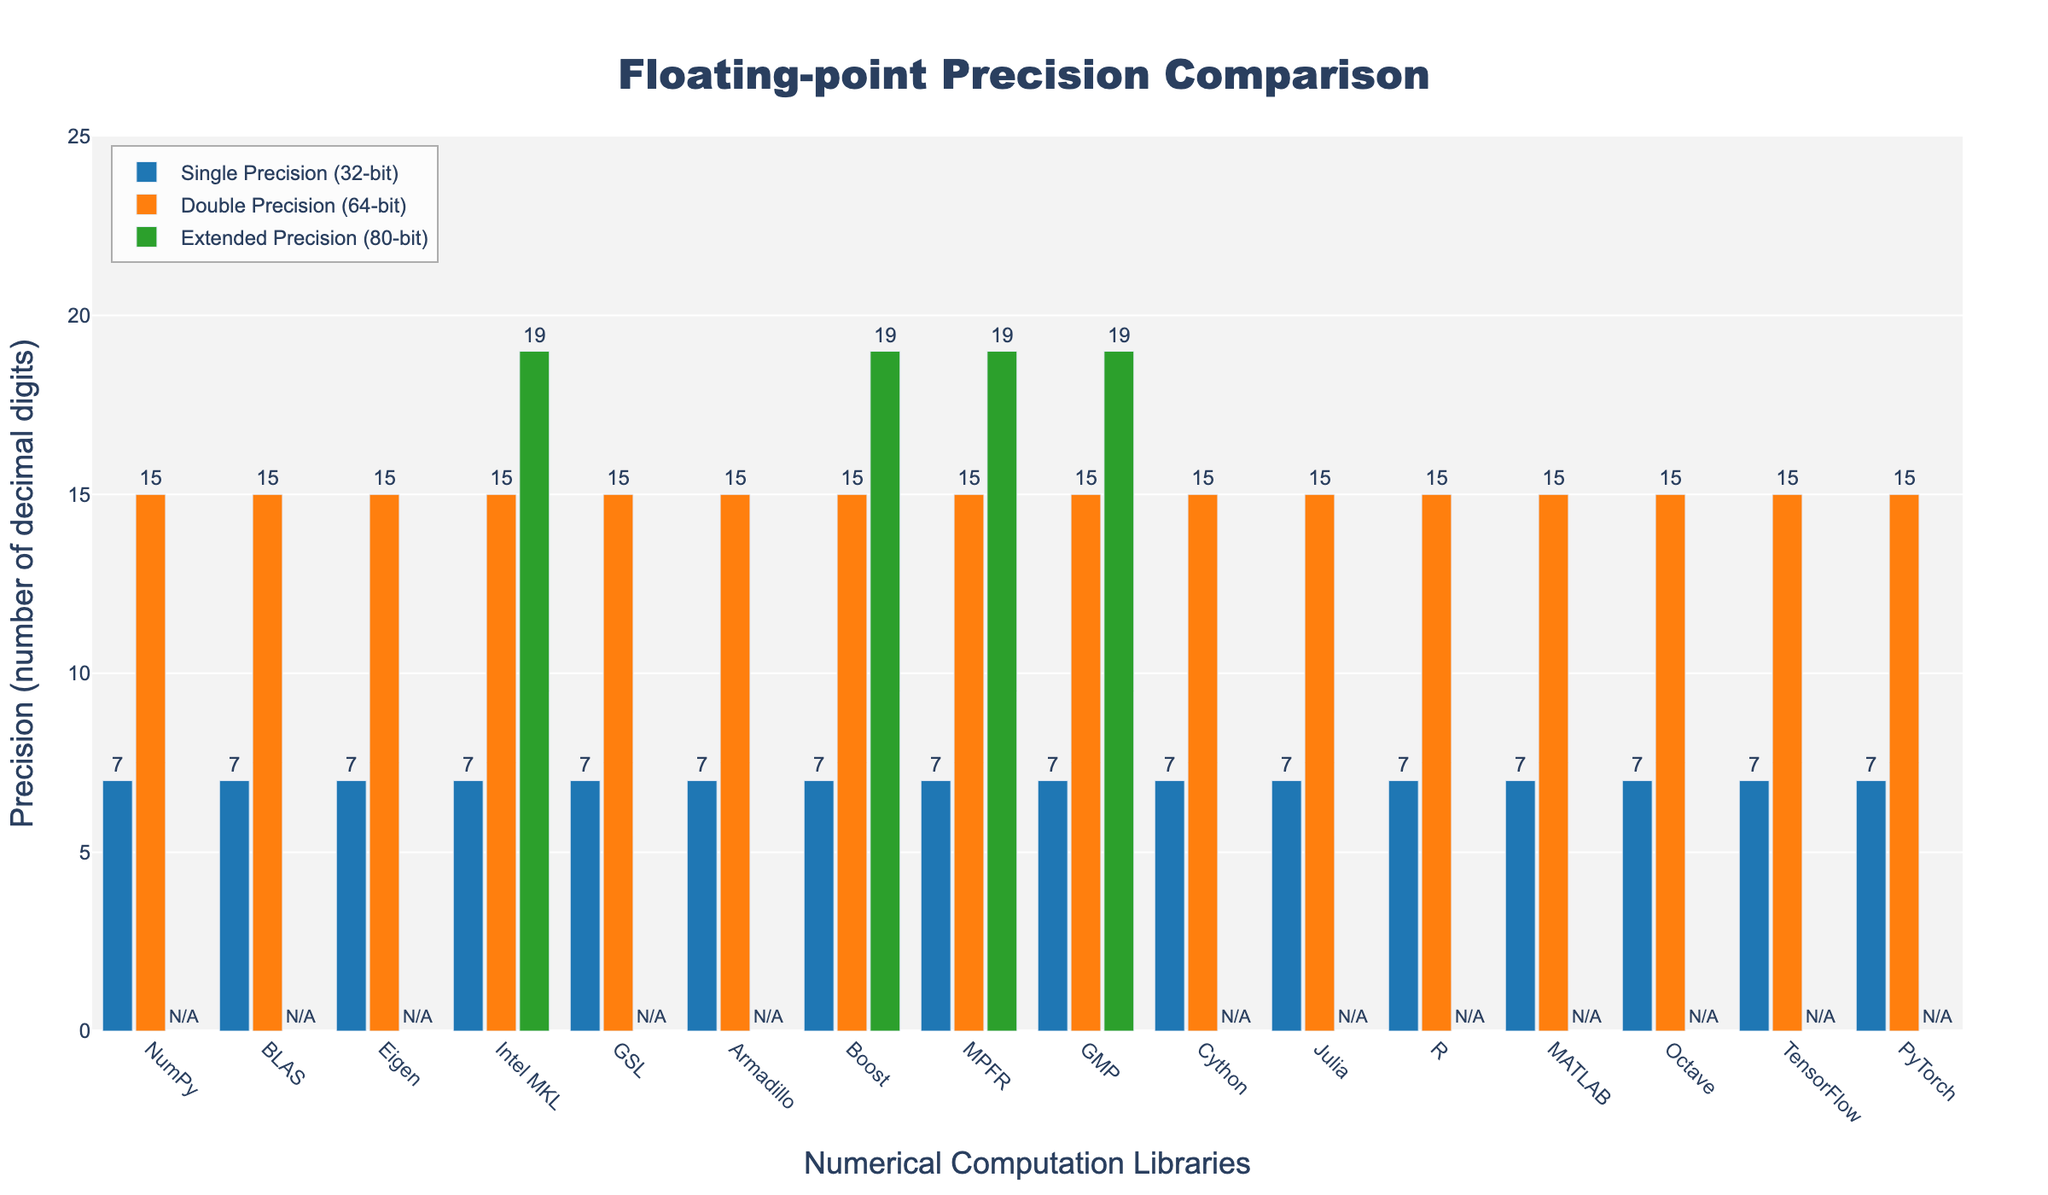What is the precision level for Double Precision (64-bit) across all listed libraries? The Double Precision (64-bit) is the same across all libraries, as shown by the orange bars in the figure, with a precision of 15 decimal digits.
Answer: 15 How many libraries support Extended Precision (80-bit)? By verifying the green bars across libraries, the ones that support Extended Precision (80-bit) include Intel MKL, Boost, MPFR, and GMP. Counting them gives us four libraries.
Answer: 4 Which library has the highest precision for Extended Precision (80-bit)? The green bar representing Extended Precision (80-bit) shows the same precision for Intel MKL, Boost, MPFR, and GMP, all having 19 decimal digits. Comparing these shows no single library has a higher precision than others in this category.
Answer: Intel MKL, Boost, MPFR, GMP Are there any libraries that do not support Extended Precision (80-bit)? By checking the green bars, or lack thereof, we can see that all libraries except Intel MKL, Boost, MPFR, and GMP show N/A or have no bar present, indicating no support for Extended Precision (80-bit). Counting them gives us thirteen such libraries.
Answer: 13 Which precision level has the most consistent value across different libraries? By observing the heights and numbers above the bars, Single Precision (32-bit) consistently shows a precision of 7 decimal digits for all libraries. Similarly, Double Precision (64-bit) has a consistent value of 15 across all libraries. Between these, both have consistent values, but Single Precision is slightly easier to notice visually all showing 7 digits.
Answer: Single Precision (32-bit), Double Precision (64-bit) How does the precision for Single Precision (32-bit) compare between NumPy and TensorFlow? Both for NumPy and TensorFlow, the blue bar representing Single Precision (32-bit) indicates a precision of 7 decimal digits. Therefore, they both have the same level of precision.
Answer: Identical Does any library have the same precision for Single Precision (32-bit) and Extended Precision (80-bit)? For Single Precision (32-bit), all libraries have a precision of 7 digits. For those with Extended Precision (80-bit), MPFR, GMP, Intel MKL, and Boost have a higher precision (19 digits), so no library has the same precision level for both.
Answer: No Which library provides the highest combined precision across all three precision levels? Since the precision levels for Single and Double precision are identical across libraries (7 and 15 respectively), checking Extended Precision (80-bit) where Intel MKL, Boost, MPFR, and GMP all show 19 decimal digits. Summing these values, all such libraries with extended precision support have 7 + 15 + 19 = 41.
Answer: Intel MKL, Boost, MPFR, GMP What is the difference in precision between Single Precision (32-bit) and Double Precision (64-bit) for the GSL library? In the figure, the Single Precision (32-bit) for GSL is shown as 7, and Double Precision (64-bit) is 15. The difference is calculated as 15 - 7 = 8.
Answer: 8 